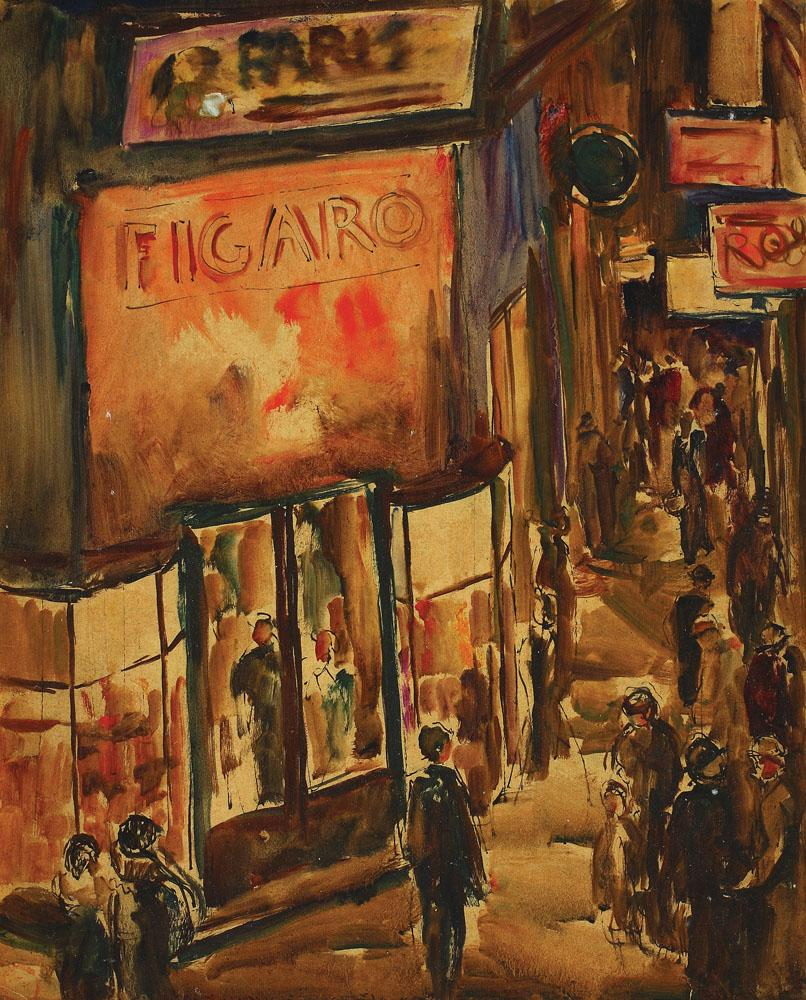Describe the following image. The image is an impressionist painting vibrantly portraying a lively street scene. The most prominent feature is a large building adorned with warm hues of orange and red, prominently displaying a sign that reads 'FIGARO'. The scene is set sometime in the early 20th century, adding a nostalgic feel to the overall composition. Through the large window of the building, mannequins can be seen, enhancing the sense of urban life. People populate the street, engaged in conversations and daily activities, captured with loose and fluid brushstrokes typical of the impressionist style. The warm, immersive color palette and the detailed bustling atmosphere evoke a rich sense of everyday life in a bygone era. 